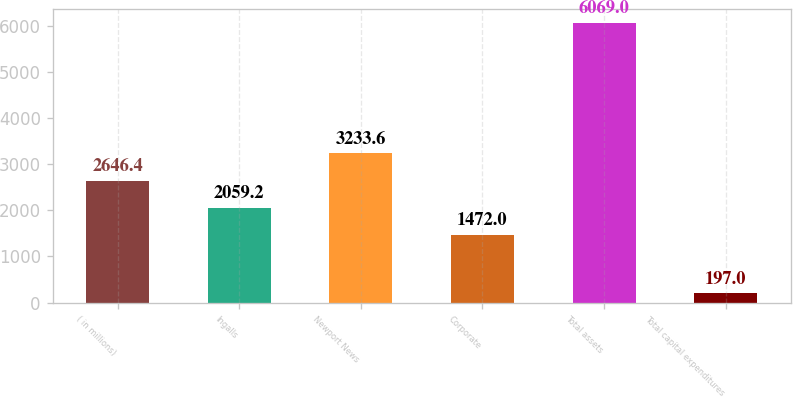<chart> <loc_0><loc_0><loc_500><loc_500><bar_chart><fcel>( in millions)<fcel>Ingalls<fcel>Newport News<fcel>Corporate<fcel>Total assets<fcel>Total capital expenditures<nl><fcel>2646.4<fcel>2059.2<fcel>3233.6<fcel>1472<fcel>6069<fcel>197<nl></chart> 